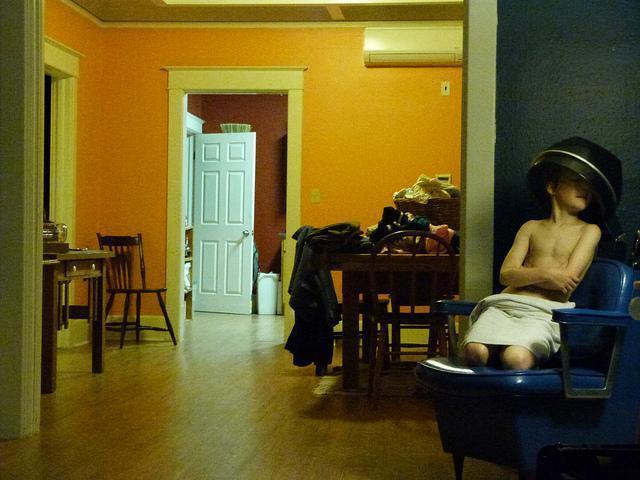How many chairs are in this photo?
Give a very brief answer. 3. How many chairs can be seen?
Give a very brief answer. 3. How many dining tables are visible?
Give a very brief answer. 2. 